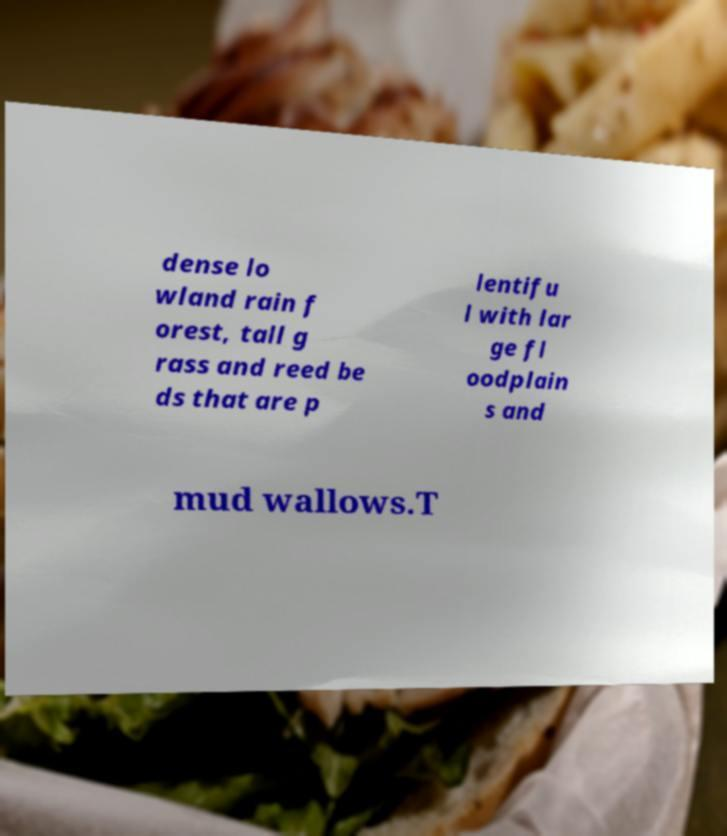Can you accurately transcribe the text from the provided image for me? dense lo wland rain f orest, tall g rass and reed be ds that are p lentifu l with lar ge fl oodplain s and mud wallows.T 